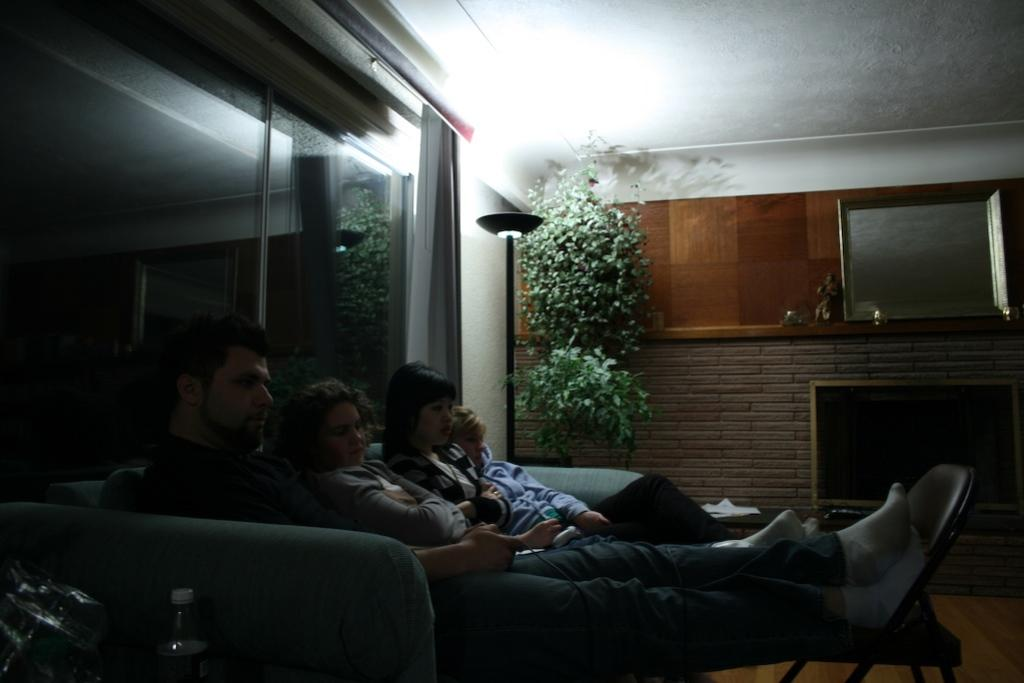How many people are sitting on the sofa in the image? There are three people sitting on the sofa in the image. What are the people doing with their legs? The people have their legs on a table in the image. What can be seen besides the sofa and people? There is a bottle, a lamp stand, trees, a wall, and a window visible in the background in the image. What type of event is the writer attending in the image? There is no writer or event present in the image; it features three people sitting on a sofa with their legs on a table. 